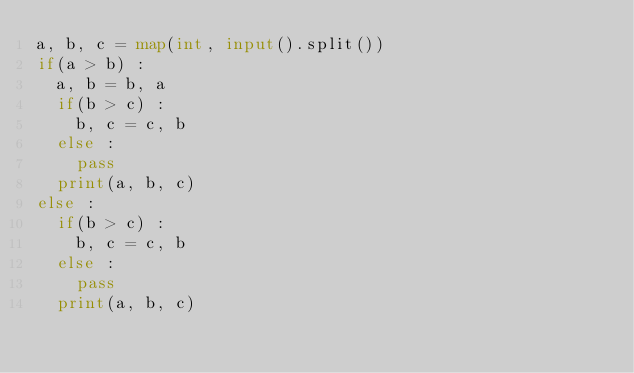Convert code to text. <code><loc_0><loc_0><loc_500><loc_500><_Python_>a, b, c = map(int, input().split())
if(a > b) :
  a, b = b, a
  if(b > c) :
    b, c = c, b
  else :
    pass
  print(a, b, c)
else :
  if(b > c) :
    b, c = c, b
  else :
    pass
  print(a, b, c)

    
  

</code> 